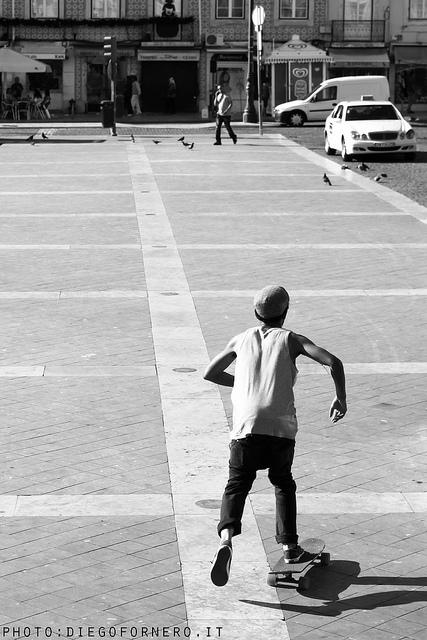What kind of refined natural resource is used to power the white car?

Choices:
A) jet fuel
B) gasoline
C) corn alcohol
D) diesel fuel gasoline 